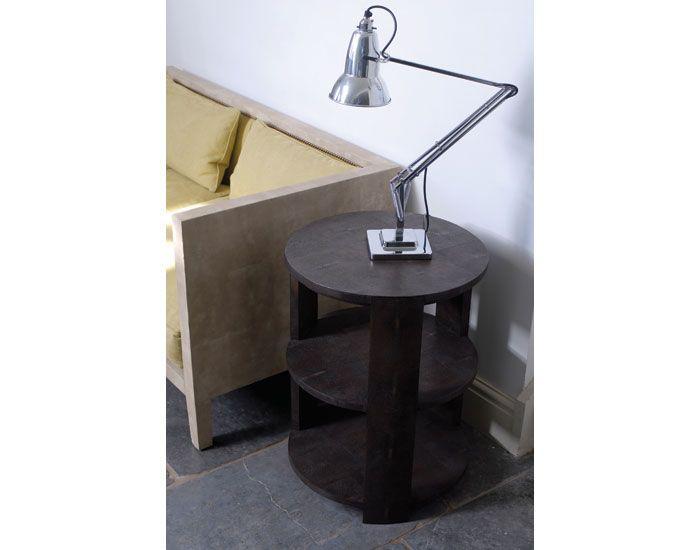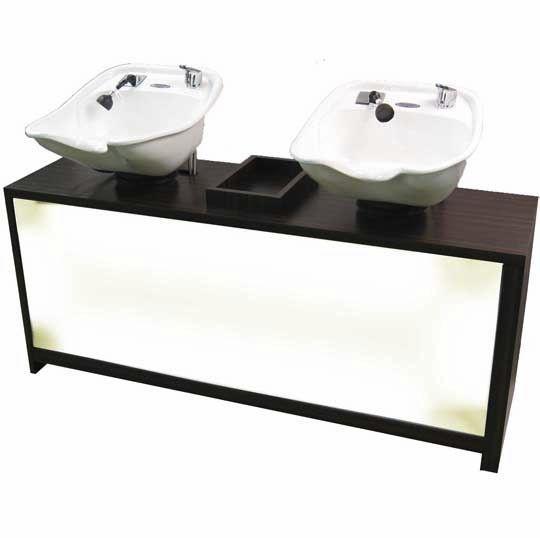The first image is the image on the left, the second image is the image on the right. Considering the images on both sides, is "One of the images features two sinks." valid? Answer yes or no. Yes. The first image is the image on the left, the second image is the image on the right. Examine the images to the left and right. Is the description "The right image features a reclined chair positioned under a small sink." accurate? Answer yes or no. No. 